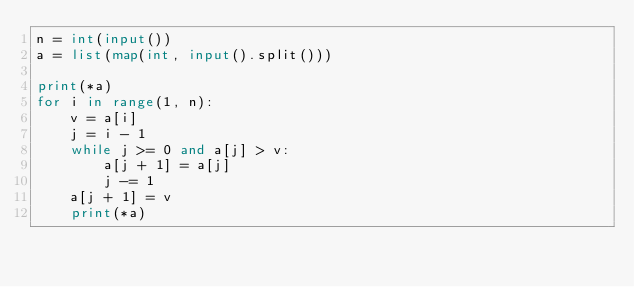Convert code to text. <code><loc_0><loc_0><loc_500><loc_500><_Python_>n = int(input())
a = list(map(int, input().split()))

print(*a)
for i in range(1, n):
    v = a[i]
    j = i - 1
    while j >= 0 and a[j] > v:
        a[j + 1] = a[j]
        j -= 1
    a[j + 1] = v
    print(*a)
</code> 